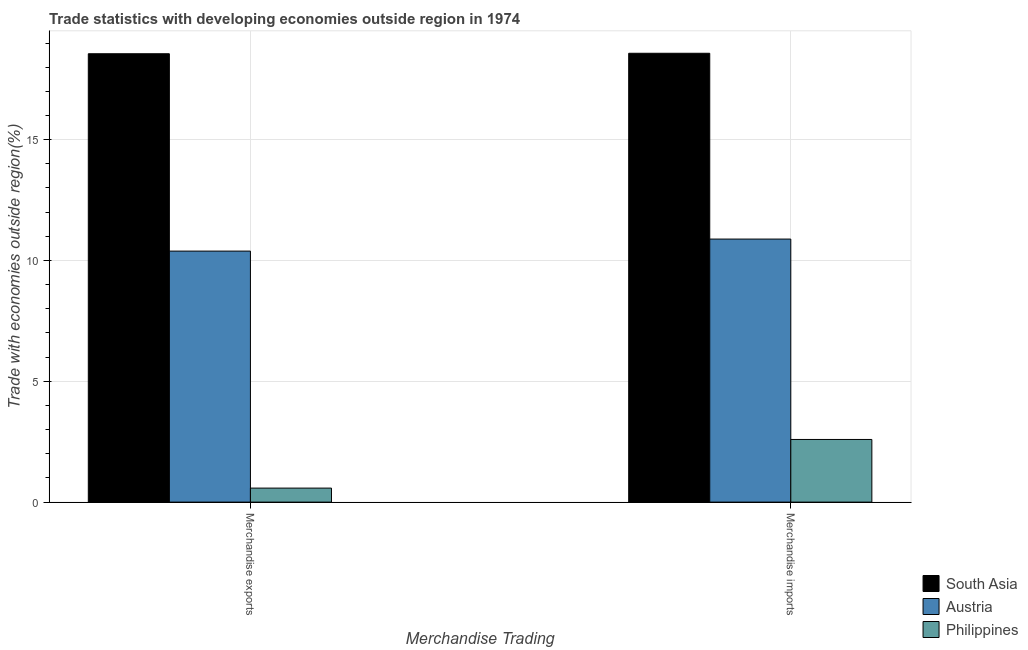How many different coloured bars are there?
Your answer should be very brief. 3. How many groups of bars are there?
Your response must be concise. 2. Are the number of bars per tick equal to the number of legend labels?
Offer a terse response. Yes. Are the number of bars on each tick of the X-axis equal?
Provide a succinct answer. Yes. How many bars are there on the 2nd tick from the right?
Ensure brevity in your answer.  3. What is the label of the 1st group of bars from the left?
Your answer should be compact. Merchandise exports. What is the merchandise imports in South Asia?
Keep it short and to the point. 18.58. Across all countries, what is the maximum merchandise imports?
Ensure brevity in your answer.  18.58. Across all countries, what is the minimum merchandise exports?
Offer a terse response. 0.58. In which country was the merchandise imports maximum?
Ensure brevity in your answer.  South Asia. What is the total merchandise exports in the graph?
Keep it short and to the point. 29.52. What is the difference between the merchandise exports in Philippines and that in Austria?
Make the answer very short. -9.81. What is the difference between the merchandise imports in Austria and the merchandise exports in Philippines?
Your response must be concise. 10.31. What is the average merchandise exports per country?
Your answer should be very brief. 9.84. What is the difference between the merchandise imports and merchandise exports in Philippines?
Ensure brevity in your answer.  2.01. What is the ratio of the merchandise exports in South Asia to that in Austria?
Provide a short and direct response. 1.79. In how many countries, is the merchandise exports greater than the average merchandise exports taken over all countries?
Make the answer very short. 2. Are all the bars in the graph horizontal?
Keep it short and to the point. No. How many countries are there in the graph?
Offer a very short reply. 3. Does the graph contain grids?
Offer a very short reply. Yes. How are the legend labels stacked?
Your response must be concise. Vertical. What is the title of the graph?
Your answer should be very brief. Trade statistics with developing economies outside region in 1974. Does "Romania" appear as one of the legend labels in the graph?
Provide a short and direct response. No. What is the label or title of the X-axis?
Offer a very short reply. Merchandise Trading. What is the label or title of the Y-axis?
Ensure brevity in your answer.  Trade with economies outside region(%). What is the Trade with economies outside region(%) in South Asia in Merchandise exports?
Your answer should be compact. 18.56. What is the Trade with economies outside region(%) in Austria in Merchandise exports?
Keep it short and to the point. 10.39. What is the Trade with economies outside region(%) in Philippines in Merchandise exports?
Offer a very short reply. 0.58. What is the Trade with economies outside region(%) of South Asia in Merchandise imports?
Offer a terse response. 18.58. What is the Trade with economies outside region(%) of Austria in Merchandise imports?
Provide a succinct answer. 10.89. What is the Trade with economies outside region(%) in Philippines in Merchandise imports?
Your answer should be compact. 2.59. Across all Merchandise Trading, what is the maximum Trade with economies outside region(%) of South Asia?
Make the answer very short. 18.58. Across all Merchandise Trading, what is the maximum Trade with economies outside region(%) in Austria?
Your answer should be compact. 10.89. Across all Merchandise Trading, what is the maximum Trade with economies outside region(%) of Philippines?
Ensure brevity in your answer.  2.59. Across all Merchandise Trading, what is the minimum Trade with economies outside region(%) in South Asia?
Offer a very short reply. 18.56. Across all Merchandise Trading, what is the minimum Trade with economies outside region(%) of Austria?
Make the answer very short. 10.39. Across all Merchandise Trading, what is the minimum Trade with economies outside region(%) of Philippines?
Your answer should be very brief. 0.58. What is the total Trade with economies outside region(%) of South Asia in the graph?
Offer a very short reply. 37.13. What is the total Trade with economies outside region(%) in Austria in the graph?
Provide a succinct answer. 21.27. What is the total Trade with economies outside region(%) in Philippines in the graph?
Provide a short and direct response. 3.17. What is the difference between the Trade with economies outside region(%) in South Asia in Merchandise exports and that in Merchandise imports?
Offer a very short reply. -0.02. What is the difference between the Trade with economies outside region(%) in Austria in Merchandise exports and that in Merchandise imports?
Offer a terse response. -0.5. What is the difference between the Trade with economies outside region(%) of Philippines in Merchandise exports and that in Merchandise imports?
Give a very brief answer. -2.01. What is the difference between the Trade with economies outside region(%) of South Asia in Merchandise exports and the Trade with economies outside region(%) of Austria in Merchandise imports?
Provide a short and direct response. 7.67. What is the difference between the Trade with economies outside region(%) of South Asia in Merchandise exports and the Trade with economies outside region(%) of Philippines in Merchandise imports?
Offer a terse response. 15.96. What is the difference between the Trade with economies outside region(%) in Austria in Merchandise exports and the Trade with economies outside region(%) in Philippines in Merchandise imports?
Make the answer very short. 7.8. What is the average Trade with economies outside region(%) in South Asia per Merchandise Trading?
Your answer should be compact. 18.57. What is the average Trade with economies outside region(%) of Austria per Merchandise Trading?
Provide a short and direct response. 10.64. What is the average Trade with economies outside region(%) in Philippines per Merchandise Trading?
Keep it short and to the point. 1.59. What is the difference between the Trade with economies outside region(%) in South Asia and Trade with economies outside region(%) in Austria in Merchandise exports?
Offer a terse response. 8.17. What is the difference between the Trade with economies outside region(%) in South Asia and Trade with economies outside region(%) in Philippines in Merchandise exports?
Your answer should be compact. 17.98. What is the difference between the Trade with economies outside region(%) in Austria and Trade with economies outside region(%) in Philippines in Merchandise exports?
Ensure brevity in your answer.  9.81. What is the difference between the Trade with economies outside region(%) of South Asia and Trade with economies outside region(%) of Austria in Merchandise imports?
Ensure brevity in your answer.  7.69. What is the difference between the Trade with economies outside region(%) in South Asia and Trade with economies outside region(%) in Philippines in Merchandise imports?
Your response must be concise. 15.98. What is the difference between the Trade with economies outside region(%) of Austria and Trade with economies outside region(%) of Philippines in Merchandise imports?
Keep it short and to the point. 8.29. What is the ratio of the Trade with economies outside region(%) of Austria in Merchandise exports to that in Merchandise imports?
Your response must be concise. 0.95. What is the ratio of the Trade with economies outside region(%) in Philippines in Merchandise exports to that in Merchandise imports?
Your response must be concise. 0.22. What is the difference between the highest and the second highest Trade with economies outside region(%) in South Asia?
Offer a terse response. 0.02. What is the difference between the highest and the second highest Trade with economies outside region(%) of Austria?
Your answer should be very brief. 0.5. What is the difference between the highest and the second highest Trade with economies outside region(%) in Philippines?
Offer a very short reply. 2.01. What is the difference between the highest and the lowest Trade with economies outside region(%) of South Asia?
Provide a succinct answer. 0.02. What is the difference between the highest and the lowest Trade with economies outside region(%) in Austria?
Offer a very short reply. 0.5. What is the difference between the highest and the lowest Trade with economies outside region(%) in Philippines?
Keep it short and to the point. 2.01. 